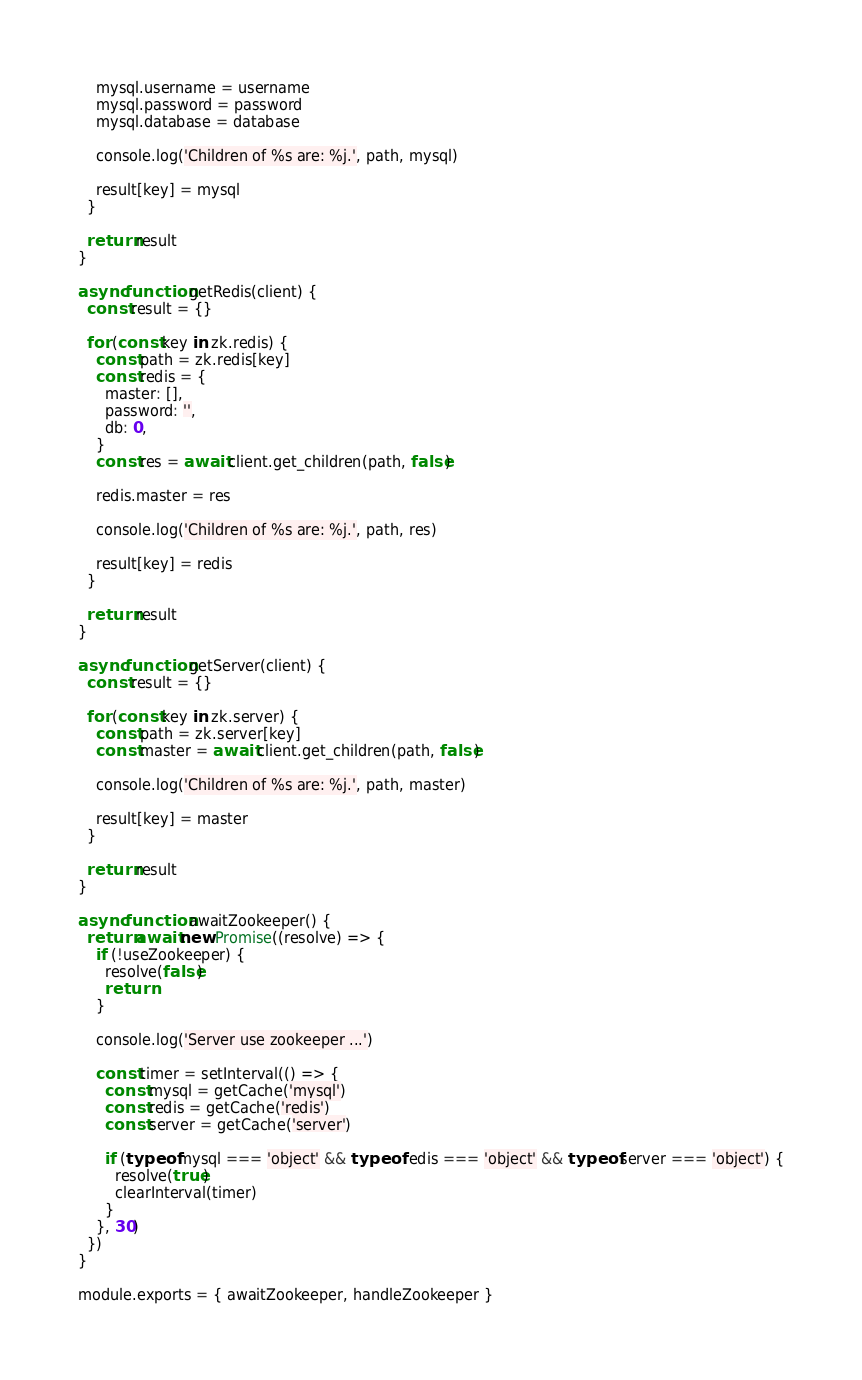Convert code to text. <code><loc_0><loc_0><loc_500><loc_500><_JavaScript_>    mysql.username = username
    mysql.password = password
    mysql.database = database

    console.log('Children of %s are: %j.', path, mysql)

    result[key] = mysql
  }

  return result
}

async function getRedis(client) {
  const result = {}

  for (const key in zk.redis) {
    const path = zk.redis[key]
    const redis = {
      master: [],
      password: '',
      db: 0,
    }
    const res = await client.get_children(path, false)

    redis.master = res

    console.log('Children of %s are: %j.', path, res)

    result[key] = redis
  }

  return result
}

async function getServer(client) {
  const result = {}

  for (const key in zk.server) {
    const path = zk.server[key]
    const master = await client.get_children(path, false)

    console.log('Children of %s are: %j.', path, master)

    result[key] = master
  }

  return result
}

async function awaitZookeeper() {
  return await new Promise((resolve) => {
    if (!useZookeeper) {
      resolve(false)
      return
    }

    console.log('Server use zookeeper ...')

    const timer = setInterval(() => {
      const mysql = getCache('mysql')
      const redis = getCache('redis')
      const server = getCache('server')

      if (typeof mysql === 'object' && typeof redis === 'object' && typeof server === 'object') {
        resolve(true)
        clearInterval(timer)
      }
    }, 30)
  })
}

module.exports = { awaitZookeeper, handleZookeeper }
</code> 